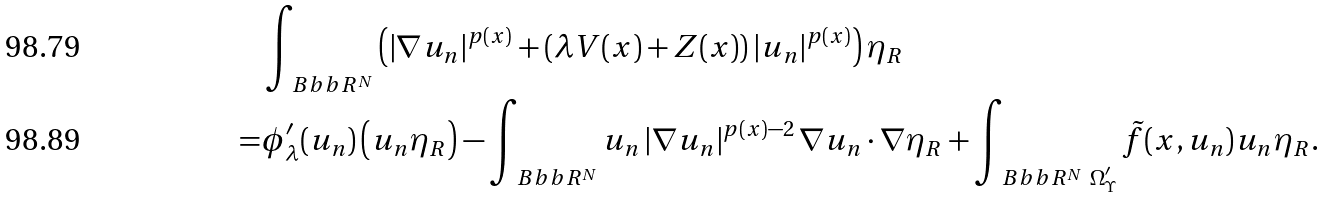Convert formula to latex. <formula><loc_0><loc_0><loc_500><loc_500>& \int _ { \ B b b R ^ { N } } \left ( \left | \nabla u _ { n } \right | ^ { p ( x ) } + \left ( \lambda V ( x ) + Z ( x ) \right ) | u _ { n } | ^ { p ( x ) } \right ) \eta _ { R } \\ = & \phi _ { \lambda } ^ { \prime } ( u _ { n } ) \left ( u _ { n } \eta _ { R } \right ) - \int _ { \ B b b R ^ { N } } u _ { n } \left | \nabla u _ { n } \right | ^ { p ( x ) - 2 } \nabla u _ { n } \cdot \nabla \eta _ { R } + \int _ { \ B b b R ^ { N } \ \Omega ^ { \prime } _ { \Upsilon } } \tilde { f } ( x , u _ { n } ) u _ { n } \eta _ { R } .</formula> 